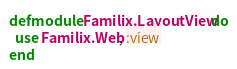Convert code to text. <code><loc_0><loc_0><loc_500><loc_500><_Elixir_>defmodule Familix.LayoutView do
  use Familix.Web, :view
end
</code> 